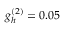Convert formula to latex. <formula><loc_0><loc_0><loc_500><loc_500>g _ { h } ^ { ( 2 ) } = 0 . 0 5</formula> 